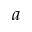Convert formula to latex. <formula><loc_0><loc_0><loc_500><loc_500>a</formula> 